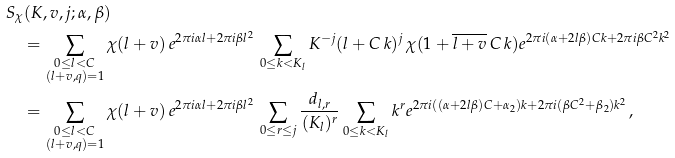<formula> <loc_0><loc_0><loc_500><loc_500>& S _ { \chi } ( K , v , j ; \alpha , \beta ) \\ & \quad = \sum _ { \substack { 0 \leq l < C \\ ( l + v , q ) = 1 } } \chi ( l + v ) \, e ^ { 2 \pi i \alpha l + 2 \pi i \beta l ^ { 2 } } \, \sum _ { 0 \leq k < K _ { l } } K ^ { - j } ( l + C \, k ) ^ { j } \, \chi ( 1 + \overline { l + v } \, C \, k ) e ^ { 2 \pi i ( \alpha + 2 l \beta ) C k + 2 \pi i \beta C ^ { 2 } k ^ { 2 } } \\ & \quad = \sum _ { \substack { 0 \leq l < C \\ ( l + v , q ) = 1 } } \chi ( l + v ) \, e ^ { 2 \pi i \alpha l + 2 \pi i \beta l ^ { 2 } } \, \sum _ { 0 \leq r \leq j } \frac { d _ { l , r } } { ( K _ { l } ) ^ { r } } \sum _ { 0 \leq k < K _ { l } } k ^ { r } e ^ { 2 \pi i ( ( \alpha + 2 l \beta ) C + \alpha _ { 2 } ) k + 2 \pi i ( \beta C ^ { 2 } + \beta _ { 2 } ) k ^ { 2 } } \, ,</formula> 